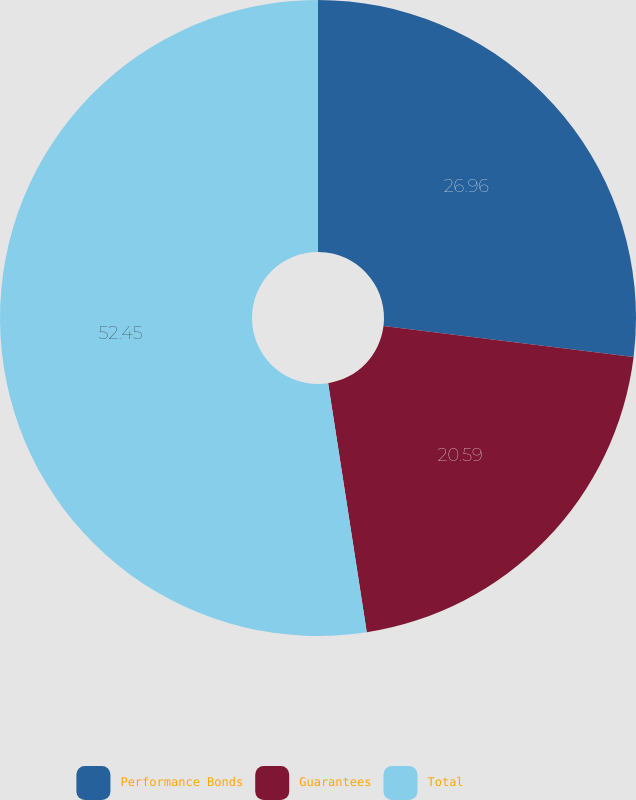<chart> <loc_0><loc_0><loc_500><loc_500><pie_chart><fcel>Performance Bonds<fcel>Guarantees<fcel>Total<nl><fcel>26.96%<fcel>20.59%<fcel>52.45%<nl></chart> 